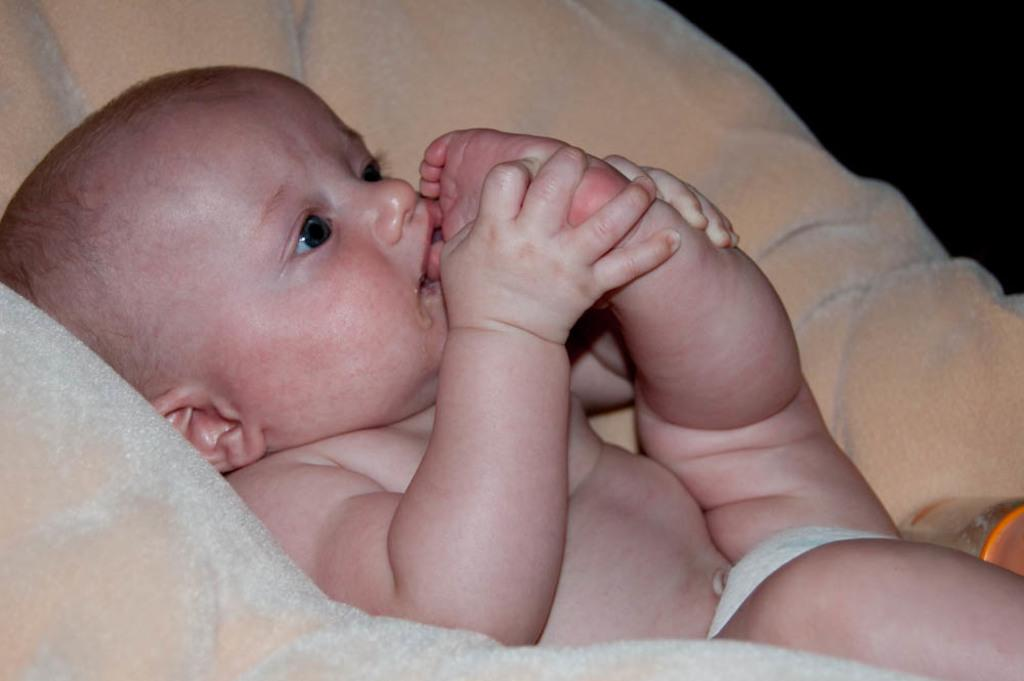What is the main subject of the image? There is a baby in the image. Where is the baby located? The baby is lying on a bed. What line does the baby draw on the bed in the image? There is no line drawn by the baby in the image, as the baby is lying on the bed. What book is the baby reading in the image? There is no book present in the image, as the baby is lying on the bed without any visible objects. 